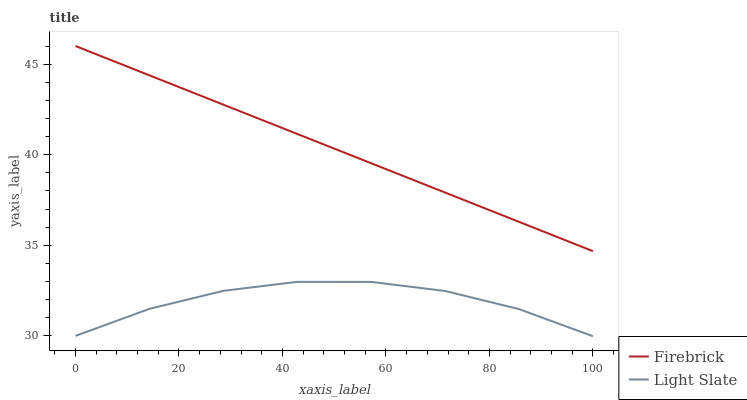Does Light Slate have the minimum area under the curve?
Answer yes or no. Yes. Does Firebrick have the maximum area under the curve?
Answer yes or no. Yes. Does Firebrick have the minimum area under the curve?
Answer yes or no. No. Is Firebrick the smoothest?
Answer yes or no. Yes. Is Light Slate the roughest?
Answer yes or no. Yes. Is Firebrick the roughest?
Answer yes or no. No. Does Light Slate have the lowest value?
Answer yes or no. Yes. Does Firebrick have the lowest value?
Answer yes or no. No. Does Firebrick have the highest value?
Answer yes or no. Yes. Is Light Slate less than Firebrick?
Answer yes or no. Yes. Is Firebrick greater than Light Slate?
Answer yes or no. Yes. Does Light Slate intersect Firebrick?
Answer yes or no. No. 